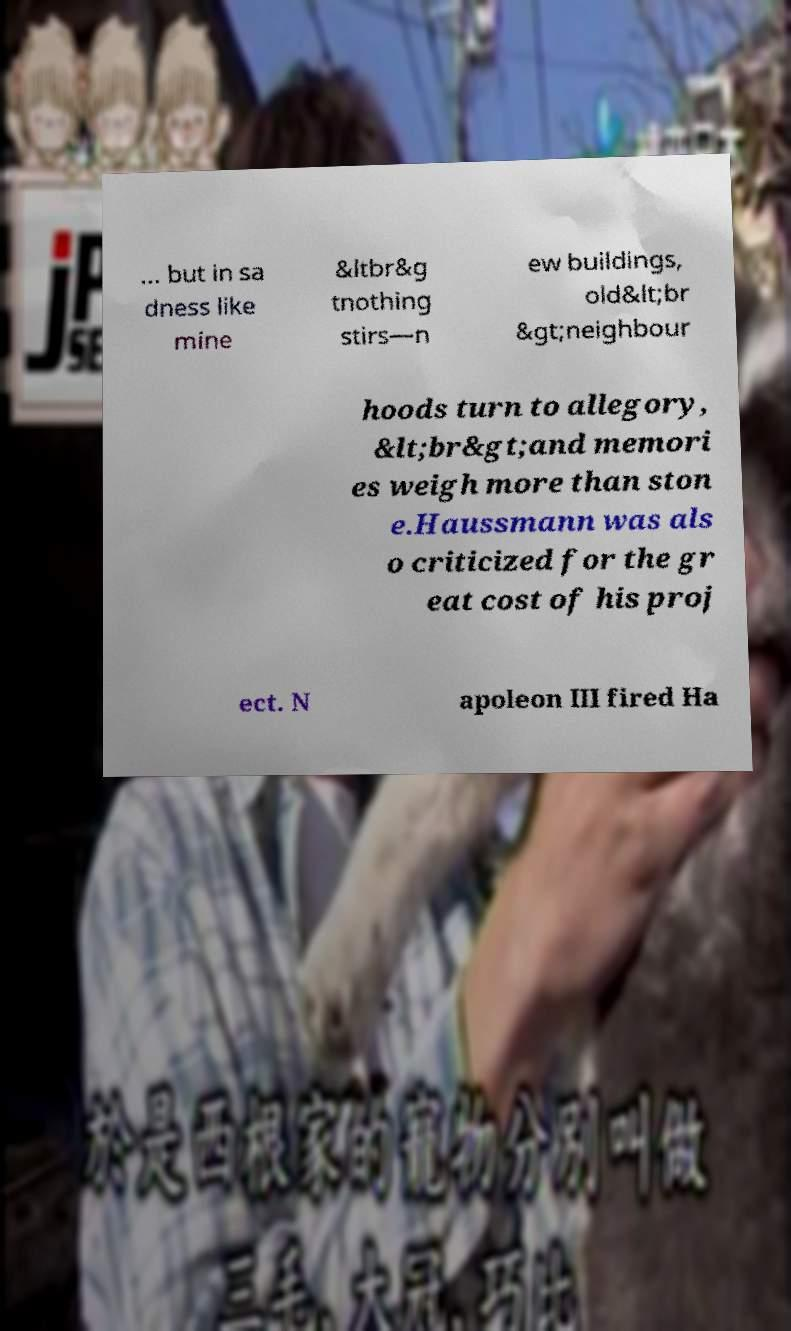Could you extract and type out the text from this image? ... but in sa dness like mine &ltbr&g tnothing stirs—n ew buildings, old&lt;br &gt;neighbour hoods turn to allegory, &lt;br&gt;and memori es weigh more than ston e.Haussmann was als o criticized for the gr eat cost of his proj ect. N apoleon III fired Ha 